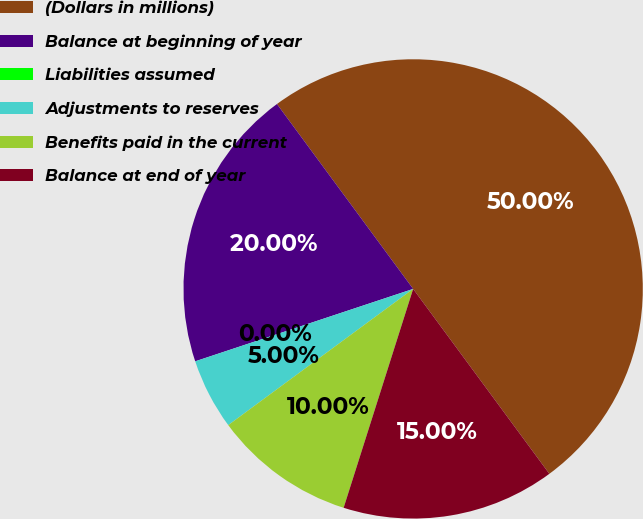Convert chart. <chart><loc_0><loc_0><loc_500><loc_500><pie_chart><fcel>(Dollars in millions)<fcel>Balance at beginning of year<fcel>Liabilities assumed<fcel>Adjustments to reserves<fcel>Benefits paid in the current<fcel>Balance at end of year<nl><fcel>50.0%<fcel>20.0%<fcel>0.0%<fcel>5.0%<fcel>10.0%<fcel>15.0%<nl></chart> 